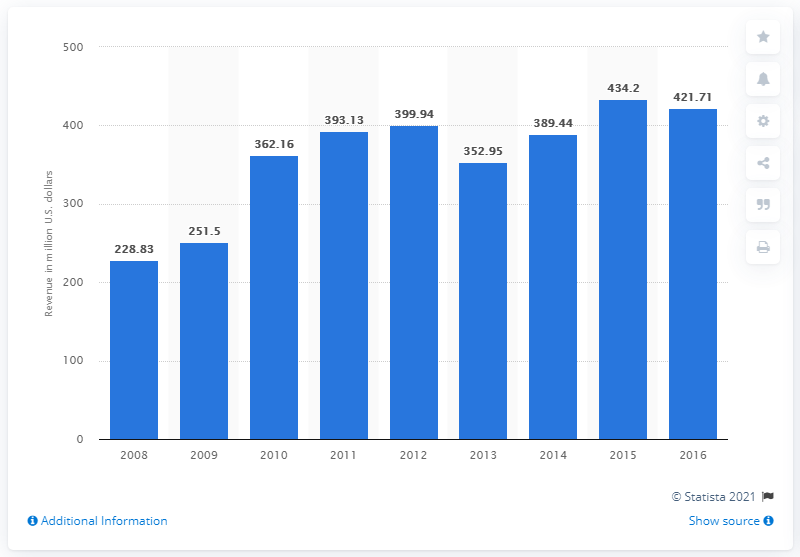Point out several critical features in this image. In 2014, Live Nation generated approximately $389.44 million in revenue from managing its signed artists. Live Nation's revenue a year earlier was 352.95. 